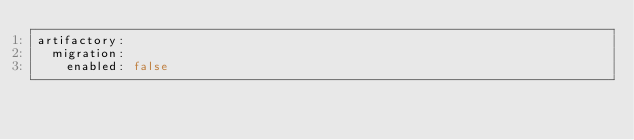<code> <loc_0><loc_0><loc_500><loc_500><_YAML_>artifactory:
  migration:
    enabled: false
</code> 